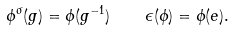<formula> <loc_0><loc_0><loc_500><loc_500>\phi ^ { \sigma } ( g ) = \phi ( g ^ { - 1 } ) \quad \epsilon ( \phi ) = \phi ( e ) .</formula> 